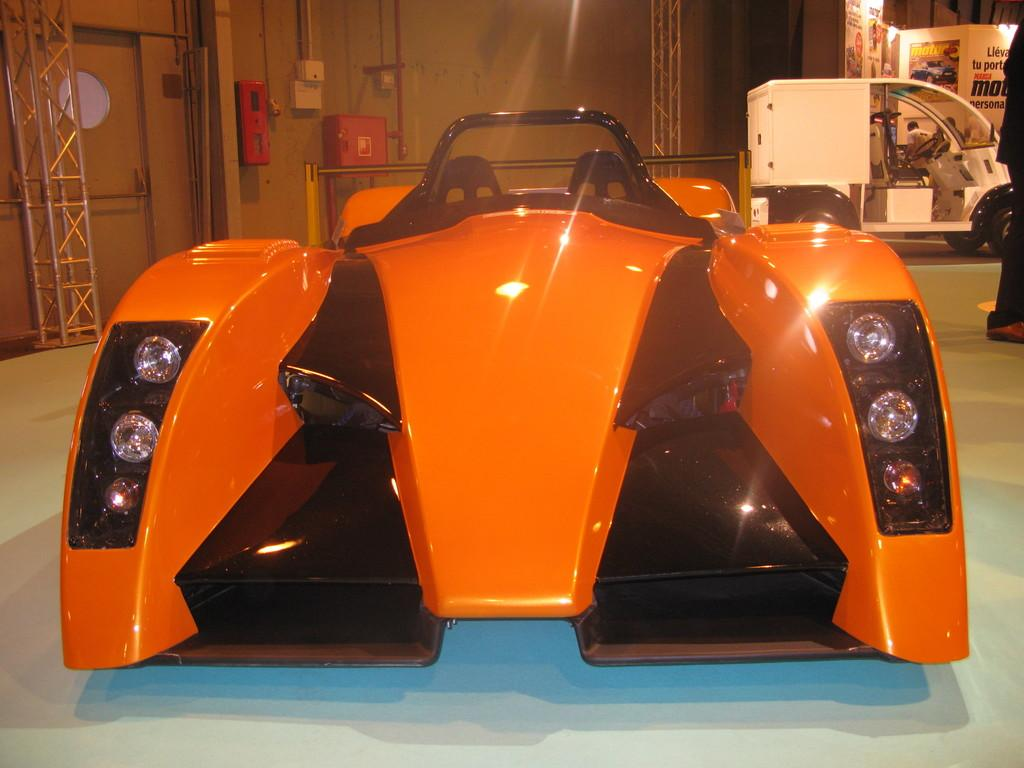What types of vehicles are present in the image? There are motor vehicles in the image. What architectural features can be seen in the image? There are iron grills, doors, and pipelines visible in the image. What type of electrical infrastructure is present in the image? There are electric cabinets in the image. What type of commercial content is present in the image? There are advertisements in the image. What is the person in the image doing? There is a person on the floor in the image. What type of stone is being used to build the government building in the image? There is no government building present in the image, and therefore no stone can be identified. What type of fangs can be seen on the person in the image? There are no fangs visible on the person in the image. 